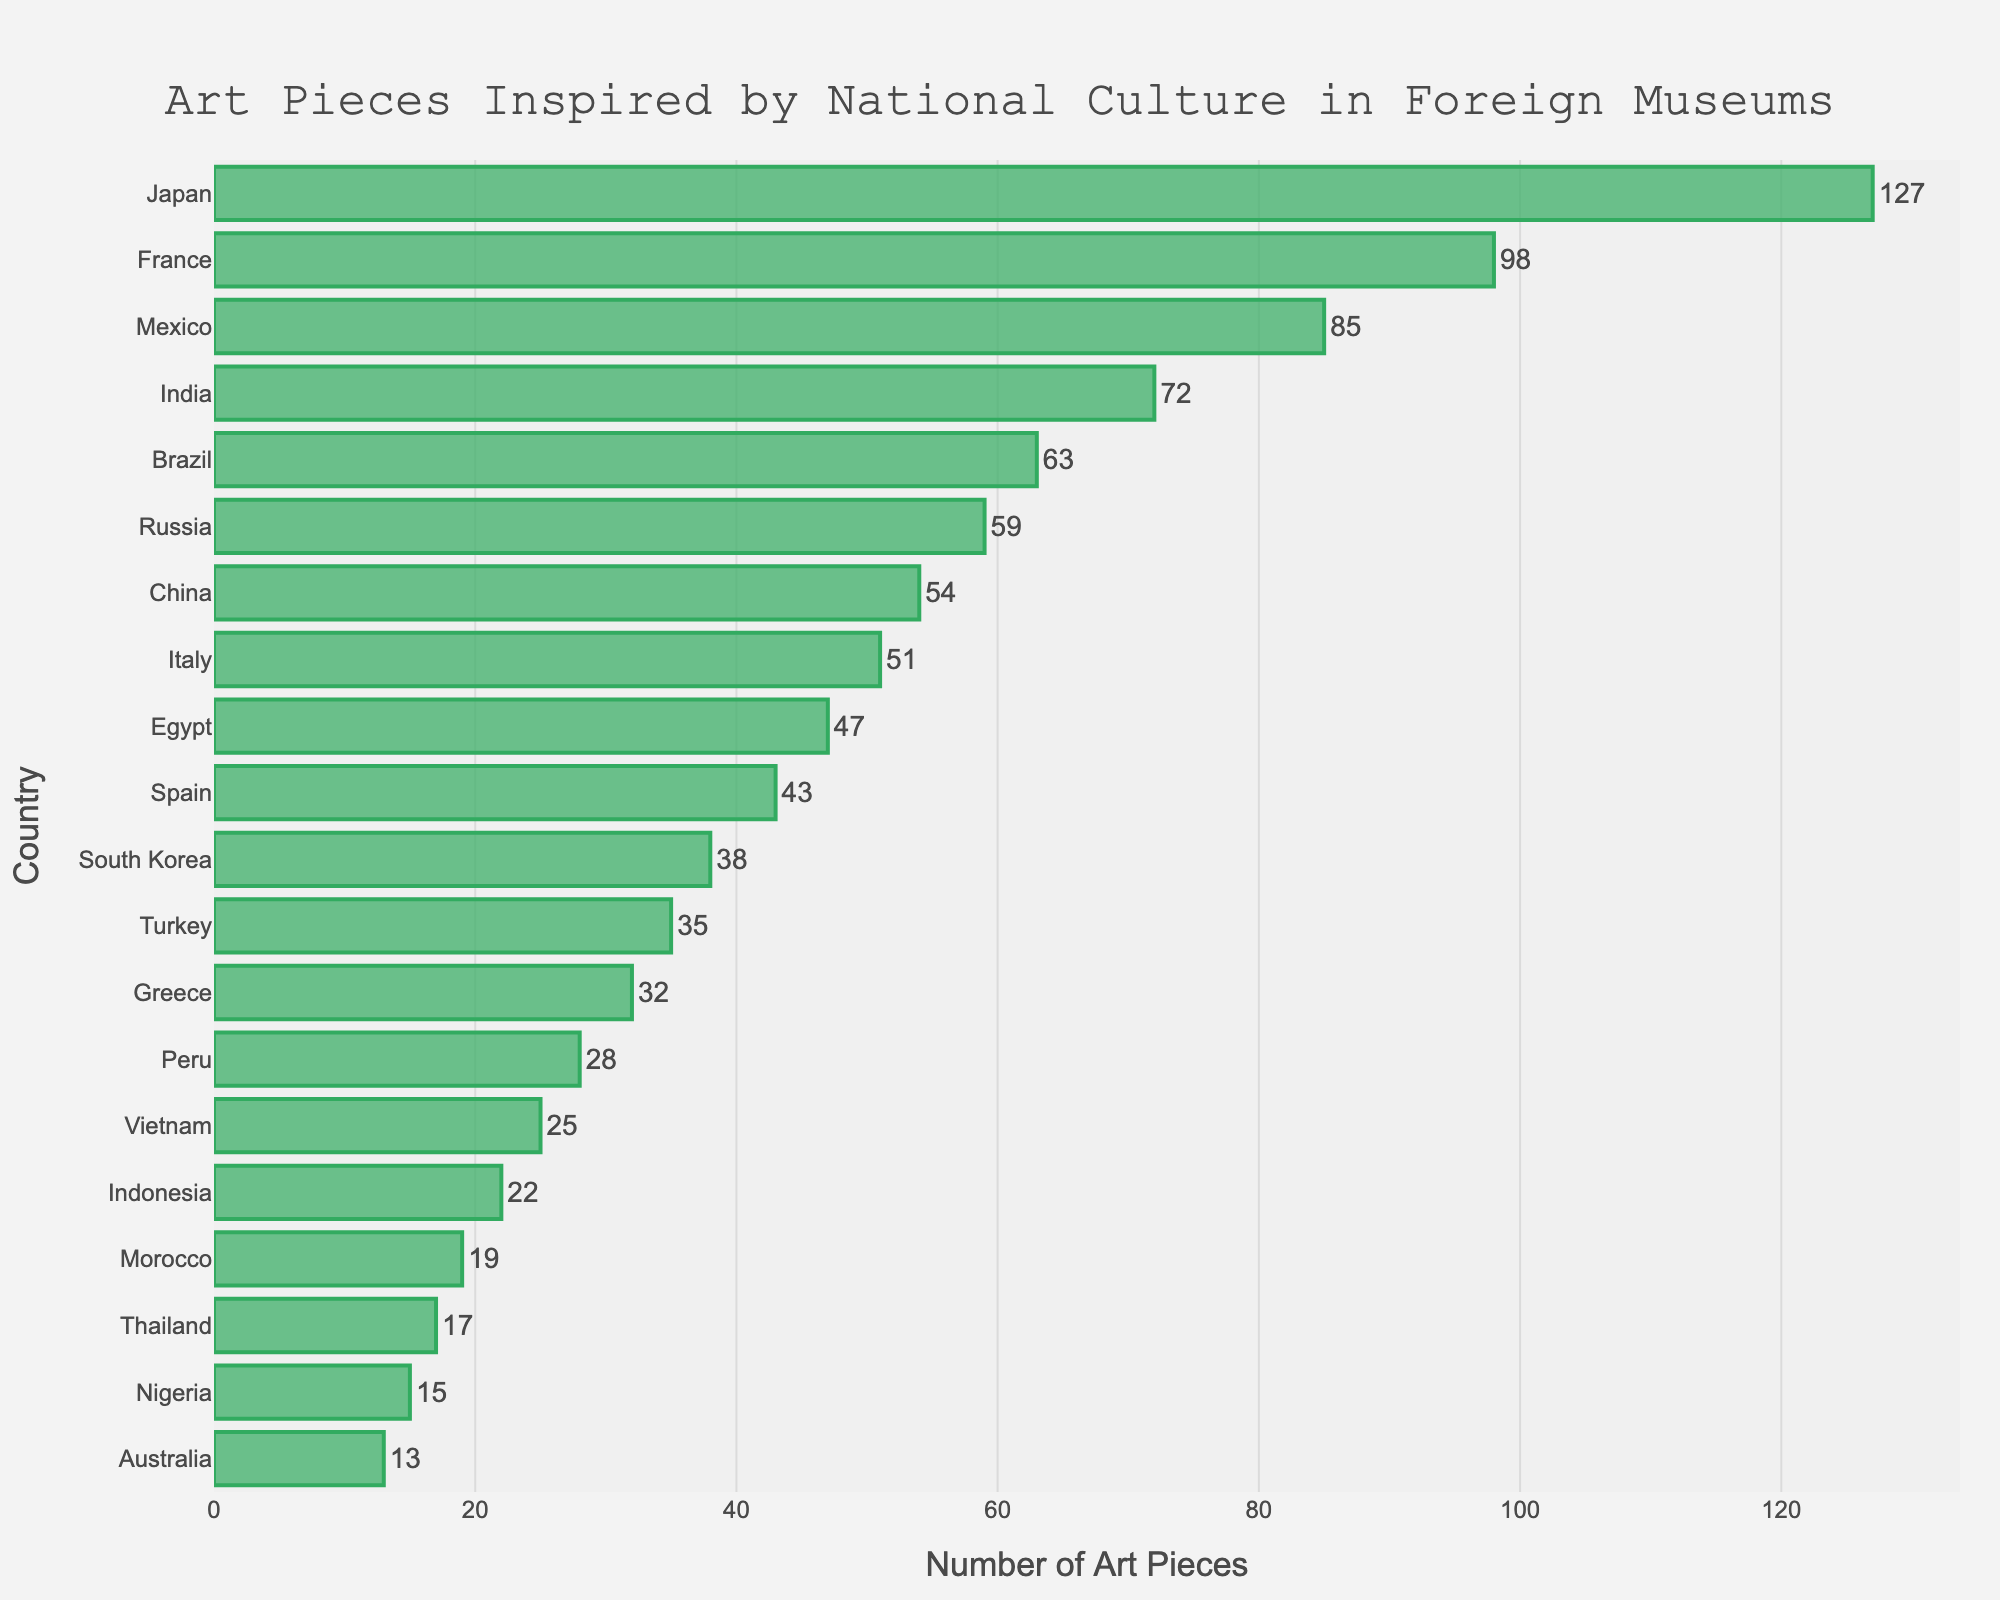which country has the highest number of art pieces inspired by national culture displayed in foreign museums? Look for the tallest bar in the chart, which represents the country with the most art pieces. In this case, the bar for Japan is the tallest.
Answer: Japan which two countries have almost the same number of art pieces displayed, within a range of three pieces? Look at the length of bars and find two that are close in length and lie within three pieces of each other. France (98) and Mexico (85) differ by more than 3, but India (72) and Brazil (63) only by 9, so none within 3.
Answer: None how many total art pieces are displayed by the top three countries combined? Sum the numbers from the top three countries: Japan (127), France (98), and Mexico (85). Calculated as 127 + 98 + 85 = 310
Answer: 310 which country has fewer art pieces displayed: Egypt or Spain? Compare the lengths of the bars for Egypt and Spain. Egypt has 47 and Spain has 43; therefore, Spain has fewer.
Answer: Spain exclude Japan; what is the difference in displayed art pieces between France and China? From the bars, France has 98 and China has 54. Subtract the two numbers: 98 - 54 = 44
Answer: 44 what is the average number of art pieces displayed for Brazil, Russia, and China? Add the numbers for Brazil (63), Russia (59), and China (54) and divide by 3. Calculated as (63 + 59 + 54) / 3 = 176 / 3 ≈ 58.67
Answer: Approximately 58.67 which country has more art pieces displayed: Nigeria or Australia? Compare the lengths of the bars for Nigeria and Australia. Nigeria has 15 and Australia has 13; therefore, Nigeria has more.
Answer: Nigeria which country with more than 40 art pieces has the fewest displayed? Look for bars with more than 40 art pieces and find the shortest among them. Spain with 43 pieces is the smallest greater than 40.
Answer: Spain what is the total number of art pieces displayed for all countries combined? Add the numbers of art pieces displayed for all countries listed: 127 + 98 + 85 + 72 + 63 + 59 + 54 + 51 + 47 + 43 + 38 + 35 + 32 + 28 + 25 + 22 + 19 + 17 + 15 + 13 = 941
Answer: 941 